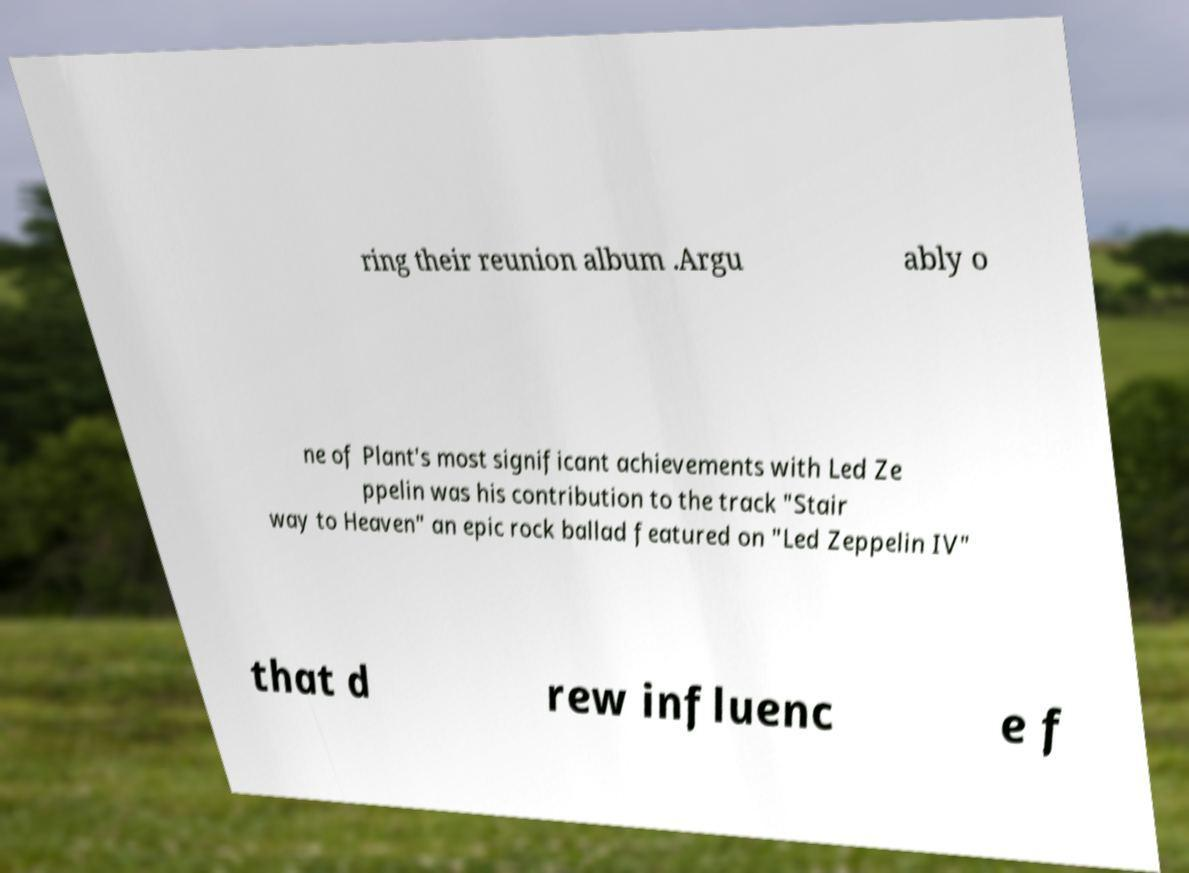Could you assist in decoding the text presented in this image and type it out clearly? ring their reunion album .Argu ably o ne of Plant's most significant achievements with Led Ze ppelin was his contribution to the track "Stair way to Heaven" an epic rock ballad featured on "Led Zeppelin IV" that d rew influenc e f 